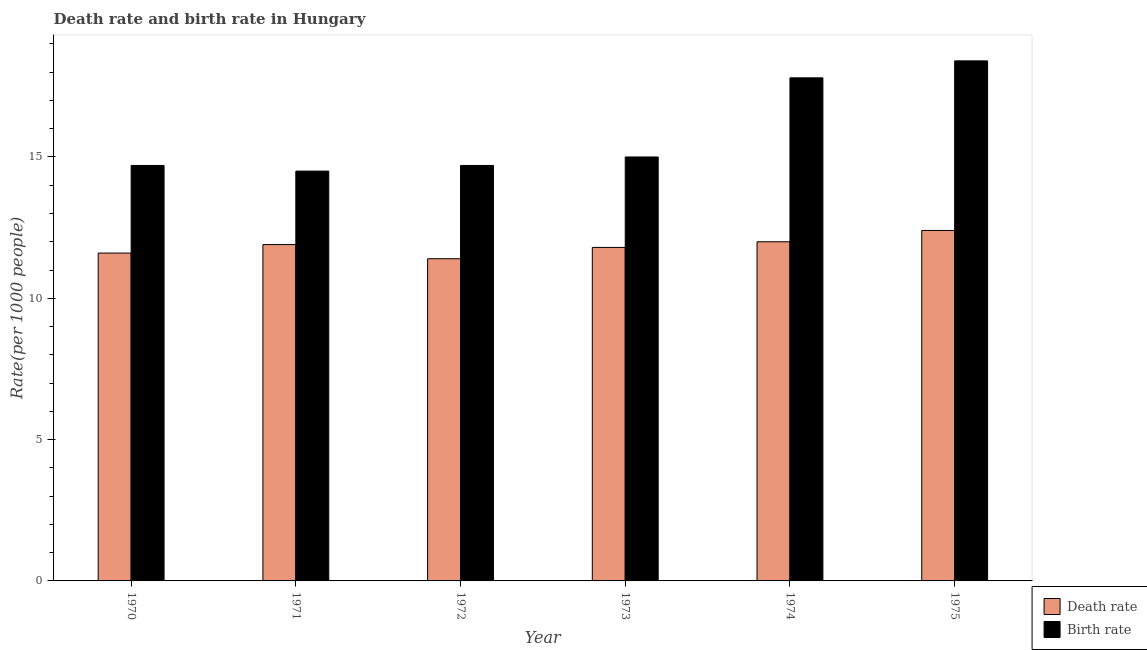Are the number of bars on each tick of the X-axis equal?
Give a very brief answer. Yes. How many bars are there on the 1st tick from the left?
Keep it short and to the point. 2. How many bars are there on the 3rd tick from the right?
Keep it short and to the point. 2. What is the label of the 1st group of bars from the left?
Keep it short and to the point. 1970. Across all years, what is the maximum birth rate?
Keep it short and to the point. 18.4. In which year was the death rate maximum?
Make the answer very short. 1975. In which year was the birth rate minimum?
Provide a succinct answer. 1971. What is the total death rate in the graph?
Ensure brevity in your answer.  71.1. What is the difference between the birth rate in 1974 and that in 1975?
Provide a succinct answer. -0.6. What is the difference between the birth rate in 1972 and the death rate in 1974?
Your answer should be very brief. -3.1. What is the average birth rate per year?
Give a very brief answer. 15.85. In how many years, is the death rate greater than 14?
Give a very brief answer. 0. What is the ratio of the death rate in 1970 to that in 1974?
Offer a terse response. 0.97. Is the death rate in 1970 less than that in 1971?
Ensure brevity in your answer.  Yes. Is the difference between the birth rate in 1972 and 1975 greater than the difference between the death rate in 1972 and 1975?
Provide a short and direct response. No. What is the difference between the highest and the second highest birth rate?
Keep it short and to the point. 0.6. What is the difference between the highest and the lowest death rate?
Give a very brief answer. 1. What does the 1st bar from the left in 1970 represents?
Offer a very short reply. Death rate. What does the 1st bar from the right in 1972 represents?
Your answer should be very brief. Birth rate. Does the graph contain any zero values?
Provide a succinct answer. No. Where does the legend appear in the graph?
Your response must be concise. Bottom right. How many legend labels are there?
Ensure brevity in your answer.  2. How are the legend labels stacked?
Your answer should be very brief. Vertical. What is the title of the graph?
Make the answer very short. Death rate and birth rate in Hungary. Does "Infant" appear as one of the legend labels in the graph?
Make the answer very short. No. What is the label or title of the X-axis?
Your answer should be compact. Year. What is the label or title of the Y-axis?
Provide a succinct answer. Rate(per 1000 people). What is the Rate(per 1000 people) in Death rate in 1970?
Offer a terse response. 11.6. What is the Rate(per 1000 people) in Death rate in 1971?
Make the answer very short. 11.9. What is the Rate(per 1000 people) of Birth rate in 1973?
Ensure brevity in your answer.  15. What is the Rate(per 1000 people) in Death rate in 1974?
Your answer should be very brief. 12. What is the Rate(per 1000 people) of Birth rate in 1974?
Keep it short and to the point. 17.8. What is the Rate(per 1000 people) in Death rate in 1975?
Offer a very short reply. 12.4. Across all years, what is the minimum Rate(per 1000 people) in Death rate?
Provide a succinct answer. 11.4. What is the total Rate(per 1000 people) of Death rate in the graph?
Offer a very short reply. 71.1. What is the total Rate(per 1000 people) in Birth rate in the graph?
Ensure brevity in your answer.  95.1. What is the difference between the Rate(per 1000 people) of Death rate in 1970 and that in 1971?
Offer a terse response. -0.3. What is the difference between the Rate(per 1000 people) in Birth rate in 1970 and that in 1971?
Provide a succinct answer. 0.2. What is the difference between the Rate(per 1000 people) of Death rate in 1970 and that in 1972?
Offer a very short reply. 0.2. What is the difference between the Rate(per 1000 people) in Birth rate in 1970 and that in 1972?
Keep it short and to the point. 0. What is the difference between the Rate(per 1000 people) in Birth rate in 1970 and that in 1973?
Give a very brief answer. -0.3. What is the difference between the Rate(per 1000 people) in Death rate in 1970 and that in 1974?
Ensure brevity in your answer.  -0.4. What is the difference between the Rate(per 1000 people) in Death rate in 1970 and that in 1975?
Your answer should be very brief. -0.8. What is the difference between the Rate(per 1000 people) in Birth rate in 1970 and that in 1975?
Keep it short and to the point. -3.7. What is the difference between the Rate(per 1000 people) in Birth rate in 1971 and that in 1972?
Your response must be concise. -0.2. What is the difference between the Rate(per 1000 people) in Death rate in 1971 and that in 1973?
Provide a succinct answer. 0.1. What is the difference between the Rate(per 1000 people) in Birth rate in 1971 and that in 1974?
Provide a succinct answer. -3.3. What is the difference between the Rate(per 1000 people) in Death rate in 1971 and that in 1975?
Your response must be concise. -0.5. What is the difference between the Rate(per 1000 people) in Birth rate in 1972 and that in 1973?
Provide a succinct answer. -0.3. What is the difference between the Rate(per 1000 people) in Death rate in 1972 and that in 1974?
Provide a short and direct response. -0.6. What is the difference between the Rate(per 1000 people) in Birth rate in 1972 and that in 1974?
Keep it short and to the point. -3.1. What is the difference between the Rate(per 1000 people) in Death rate in 1972 and that in 1975?
Provide a succinct answer. -1. What is the difference between the Rate(per 1000 people) in Death rate in 1973 and that in 1974?
Offer a terse response. -0.2. What is the difference between the Rate(per 1000 people) in Birth rate in 1973 and that in 1974?
Offer a terse response. -2.8. What is the difference between the Rate(per 1000 people) of Birth rate in 1973 and that in 1975?
Your answer should be compact. -3.4. What is the difference between the Rate(per 1000 people) in Death rate in 1974 and that in 1975?
Offer a very short reply. -0.4. What is the difference between the Rate(per 1000 people) in Birth rate in 1974 and that in 1975?
Provide a succinct answer. -0.6. What is the difference between the Rate(per 1000 people) of Death rate in 1970 and the Rate(per 1000 people) of Birth rate in 1971?
Keep it short and to the point. -2.9. What is the difference between the Rate(per 1000 people) of Death rate in 1970 and the Rate(per 1000 people) of Birth rate in 1973?
Keep it short and to the point. -3.4. What is the difference between the Rate(per 1000 people) of Death rate in 1970 and the Rate(per 1000 people) of Birth rate in 1974?
Give a very brief answer. -6.2. What is the difference between the Rate(per 1000 people) of Death rate in 1971 and the Rate(per 1000 people) of Birth rate in 1973?
Offer a very short reply. -3.1. What is the difference between the Rate(per 1000 people) of Death rate in 1972 and the Rate(per 1000 people) of Birth rate in 1974?
Offer a very short reply. -6.4. What is the difference between the Rate(per 1000 people) in Death rate in 1973 and the Rate(per 1000 people) in Birth rate in 1974?
Ensure brevity in your answer.  -6. What is the difference between the Rate(per 1000 people) of Death rate in 1973 and the Rate(per 1000 people) of Birth rate in 1975?
Give a very brief answer. -6.6. What is the difference between the Rate(per 1000 people) of Death rate in 1974 and the Rate(per 1000 people) of Birth rate in 1975?
Provide a short and direct response. -6.4. What is the average Rate(per 1000 people) of Death rate per year?
Give a very brief answer. 11.85. What is the average Rate(per 1000 people) in Birth rate per year?
Provide a short and direct response. 15.85. In the year 1971, what is the difference between the Rate(per 1000 people) in Death rate and Rate(per 1000 people) in Birth rate?
Provide a short and direct response. -2.6. In the year 1972, what is the difference between the Rate(per 1000 people) in Death rate and Rate(per 1000 people) in Birth rate?
Give a very brief answer. -3.3. In the year 1973, what is the difference between the Rate(per 1000 people) of Death rate and Rate(per 1000 people) of Birth rate?
Keep it short and to the point. -3.2. In the year 1975, what is the difference between the Rate(per 1000 people) in Death rate and Rate(per 1000 people) in Birth rate?
Offer a very short reply. -6. What is the ratio of the Rate(per 1000 people) in Death rate in 1970 to that in 1971?
Your response must be concise. 0.97. What is the ratio of the Rate(per 1000 people) of Birth rate in 1970 to that in 1971?
Offer a very short reply. 1.01. What is the ratio of the Rate(per 1000 people) of Death rate in 1970 to that in 1972?
Your answer should be very brief. 1.02. What is the ratio of the Rate(per 1000 people) of Death rate in 1970 to that in 1973?
Ensure brevity in your answer.  0.98. What is the ratio of the Rate(per 1000 people) of Death rate in 1970 to that in 1974?
Your answer should be compact. 0.97. What is the ratio of the Rate(per 1000 people) in Birth rate in 1970 to that in 1974?
Your answer should be very brief. 0.83. What is the ratio of the Rate(per 1000 people) of Death rate in 1970 to that in 1975?
Provide a short and direct response. 0.94. What is the ratio of the Rate(per 1000 people) in Birth rate in 1970 to that in 1975?
Your answer should be very brief. 0.8. What is the ratio of the Rate(per 1000 people) of Death rate in 1971 to that in 1972?
Offer a very short reply. 1.04. What is the ratio of the Rate(per 1000 people) of Birth rate in 1971 to that in 1972?
Your answer should be very brief. 0.99. What is the ratio of the Rate(per 1000 people) in Death rate in 1971 to that in 1973?
Offer a very short reply. 1.01. What is the ratio of the Rate(per 1000 people) of Birth rate in 1971 to that in 1973?
Your answer should be very brief. 0.97. What is the ratio of the Rate(per 1000 people) of Death rate in 1971 to that in 1974?
Offer a terse response. 0.99. What is the ratio of the Rate(per 1000 people) of Birth rate in 1971 to that in 1974?
Provide a succinct answer. 0.81. What is the ratio of the Rate(per 1000 people) in Death rate in 1971 to that in 1975?
Keep it short and to the point. 0.96. What is the ratio of the Rate(per 1000 people) of Birth rate in 1971 to that in 1975?
Keep it short and to the point. 0.79. What is the ratio of the Rate(per 1000 people) in Death rate in 1972 to that in 1973?
Your answer should be very brief. 0.97. What is the ratio of the Rate(per 1000 people) of Birth rate in 1972 to that in 1973?
Give a very brief answer. 0.98. What is the ratio of the Rate(per 1000 people) of Death rate in 1972 to that in 1974?
Your response must be concise. 0.95. What is the ratio of the Rate(per 1000 people) of Birth rate in 1972 to that in 1974?
Offer a very short reply. 0.83. What is the ratio of the Rate(per 1000 people) in Death rate in 1972 to that in 1975?
Keep it short and to the point. 0.92. What is the ratio of the Rate(per 1000 people) of Birth rate in 1972 to that in 1975?
Offer a terse response. 0.8. What is the ratio of the Rate(per 1000 people) in Death rate in 1973 to that in 1974?
Offer a terse response. 0.98. What is the ratio of the Rate(per 1000 people) of Birth rate in 1973 to that in 1974?
Make the answer very short. 0.84. What is the ratio of the Rate(per 1000 people) in Death rate in 1973 to that in 1975?
Your answer should be compact. 0.95. What is the ratio of the Rate(per 1000 people) of Birth rate in 1973 to that in 1975?
Offer a very short reply. 0.82. What is the ratio of the Rate(per 1000 people) of Birth rate in 1974 to that in 1975?
Your answer should be compact. 0.97. What is the difference between the highest and the second highest Rate(per 1000 people) in Death rate?
Make the answer very short. 0.4. What is the difference between the highest and the lowest Rate(per 1000 people) of Death rate?
Provide a succinct answer. 1. What is the difference between the highest and the lowest Rate(per 1000 people) in Birth rate?
Your answer should be compact. 3.9. 